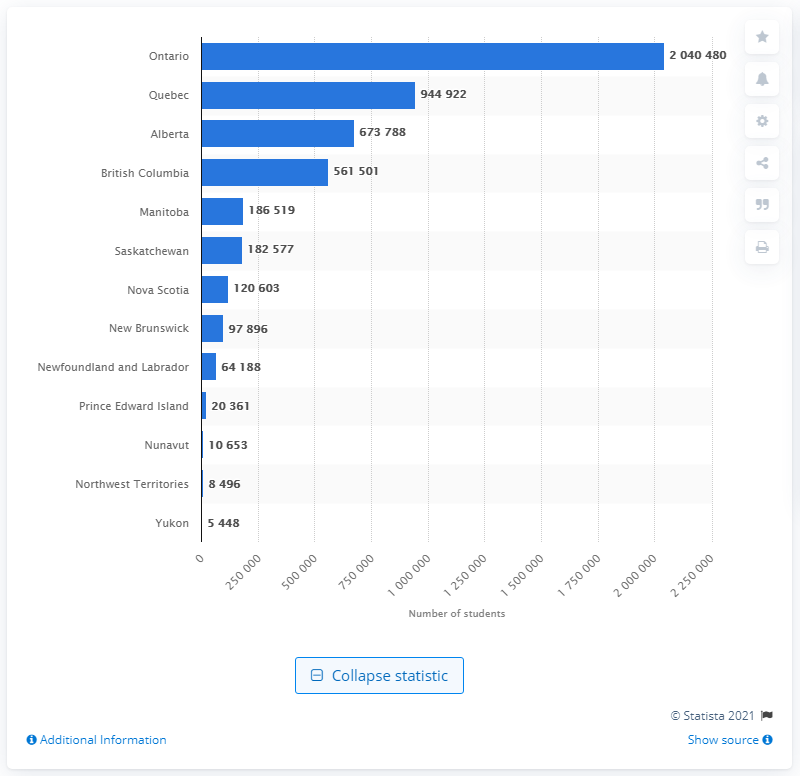Point out several critical features in this image. In the 2018/19 school year, a total of 204,048 students were enrolled in public elementary and secondary schools in Ontario. 